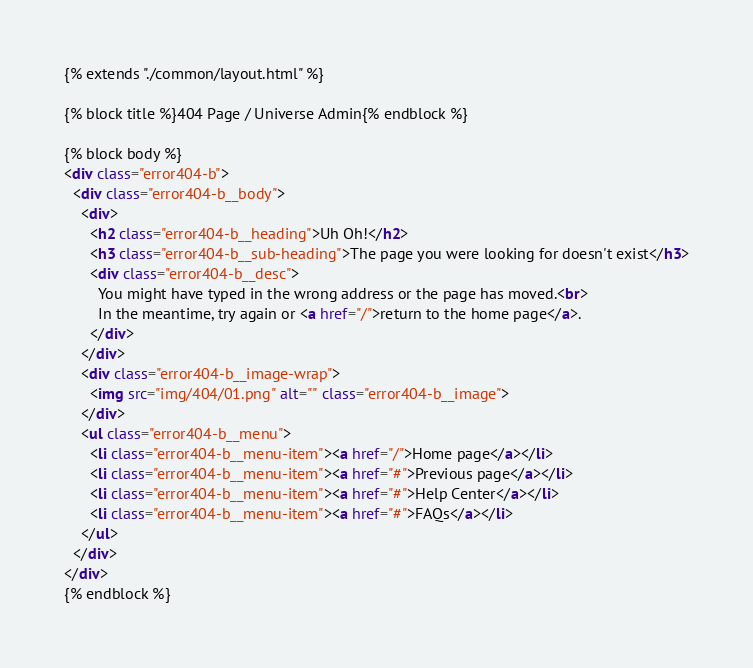<code> <loc_0><loc_0><loc_500><loc_500><_HTML_>{% extends "./common/layout.html" %}

{% block title %}404 Page / Universe Admin{% endblock %}

{% block body %}
<div class="error404-b">
  <div class="error404-b__body">
    <div>
      <h2 class="error404-b__heading">Uh Oh!</h2>
      <h3 class="error404-b__sub-heading">The page you were looking for doesn't exist</h3>
      <div class="error404-b__desc">
        You might have typed in the wrong address or the page has moved.<br>
        In the meantime, try again or <a href="/">return to the home page</a>.
      </div>
    </div>
    <div class="error404-b__image-wrap">
      <img src="img/404/01.png" alt="" class="error404-b__image">
    </div>
    <ul class="error404-b__menu">
      <li class="error404-b__menu-item"><a href="/">Home page</a></li>
      <li class="error404-b__menu-item"><a href="#">Previous page</a></li>
      <li class="error404-b__menu-item"><a href="#">Help Center</a></li>
      <li class="error404-b__menu-item"><a href="#">FAQs</a></li>
    </ul>
  </div>
</div>
{% endblock %}
</code> 